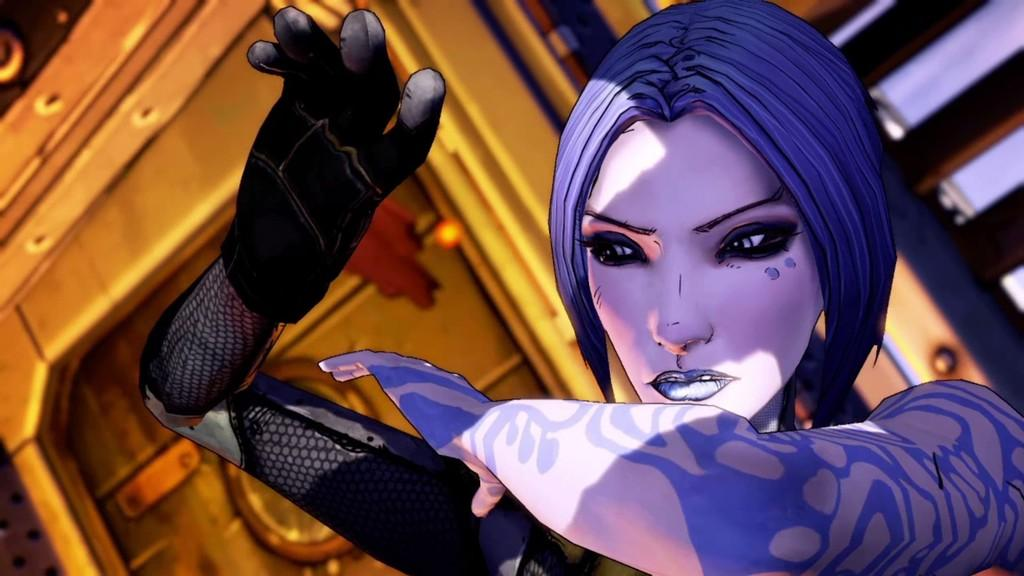What type of image is being described? The image is animated. Can you describe the main subject in the image? There is a person in the image. What type of school can be seen in the image? There is no school present in the image; it is an animated image with a person as the main subject. How does the mist affect the person in the image? There is no mist present in the image; it is an animated image with a person as the main subject. 